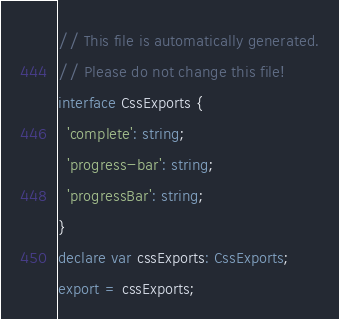Convert code to text. <code><loc_0><loc_0><loc_500><loc_500><_TypeScript_>// This file is automatically generated.
// Please do not change this file!
interface CssExports {
  'complete': string;
  'progress-bar': string;
  'progressBar': string;
}
declare var cssExports: CssExports;
export = cssExports;
</code> 